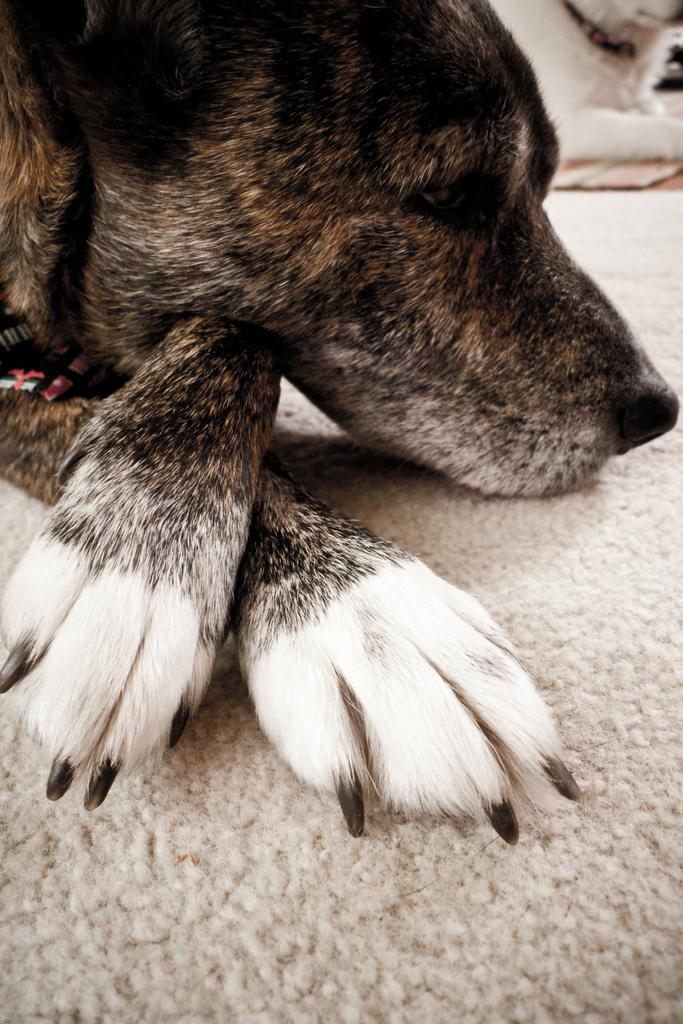What type of animal can be seen in the image? There is a partial part of a dog in the picture. Where is the dog located in the image? The dog is in the top right corner of the image. What type of flooring is visible in the image? There is a carpet visible at the bottom portion of the image. What type of butter is being used to patch the cast in the image? There is no butter, patch, or cast present in the image. 